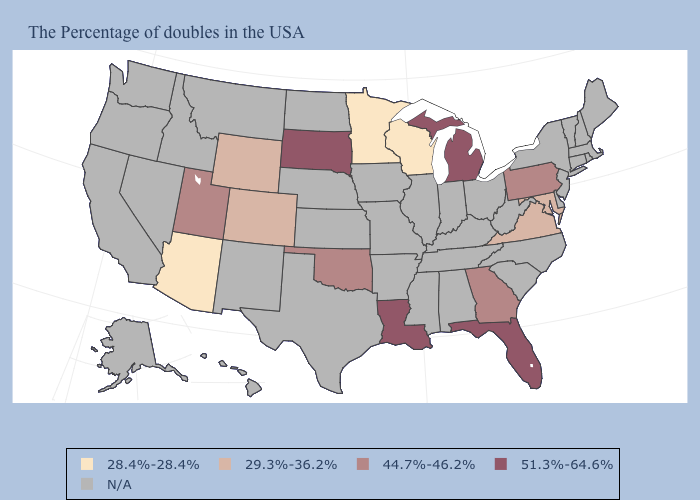What is the value of Maryland?
Answer briefly. 29.3%-36.2%. Name the states that have a value in the range 28.4%-28.4%?
Answer briefly. Wisconsin, Minnesota, Arizona. Does Colorado have the highest value in the USA?
Be succinct. No. Among the states that border New Jersey , which have the lowest value?
Short answer required. Pennsylvania. Name the states that have a value in the range 28.4%-28.4%?
Short answer required. Wisconsin, Minnesota, Arizona. Is the legend a continuous bar?
Keep it brief. No. Does the first symbol in the legend represent the smallest category?
Keep it brief. Yes. What is the value of Connecticut?
Quick response, please. N/A. What is the value of New York?
Short answer required. N/A. Name the states that have a value in the range 51.3%-64.6%?
Give a very brief answer. Florida, Michigan, Louisiana, South Dakota. What is the lowest value in the USA?
Answer briefly. 28.4%-28.4%. Among the states that border Delaware , does Maryland have the highest value?
Give a very brief answer. No. Name the states that have a value in the range 29.3%-36.2%?
Quick response, please. Maryland, Virginia, Wyoming, Colorado. 